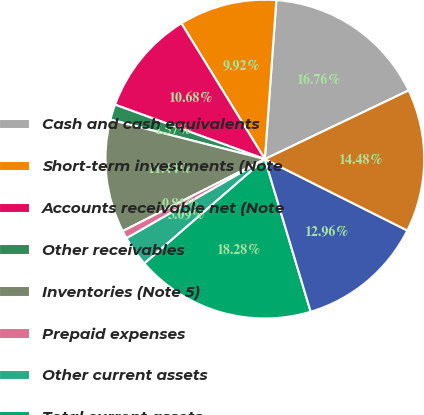Convert chart. <chart><loc_0><loc_0><loc_500><loc_500><pie_chart><fcel>Cash and cash equivalents<fcel>Short-term investments (Note<fcel>Accounts receivable net (Note<fcel>Other receivables<fcel>Inventories (Note 5)<fcel>Prepaid expenses<fcel>Other current assets<fcel>Total current assets<fcel>Long-term investments (Note 6)<fcel>Property plant and equipment<nl><fcel>16.76%<fcel>9.92%<fcel>10.68%<fcel>1.57%<fcel>11.44%<fcel>0.81%<fcel>3.09%<fcel>18.28%<fcel>12.96%<fcel>14.48%<nl></chart> 